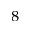Convert formula to latex. <formula><loc_0><loc_0><loc_500><loc_500>_ { 8 }</formula> 